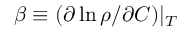<formula> <loc_0><loc_0><loc_500><loc_500>\beta \equiv ( \partial \ln \rho / \partial C ) | _ { T }</formula> 